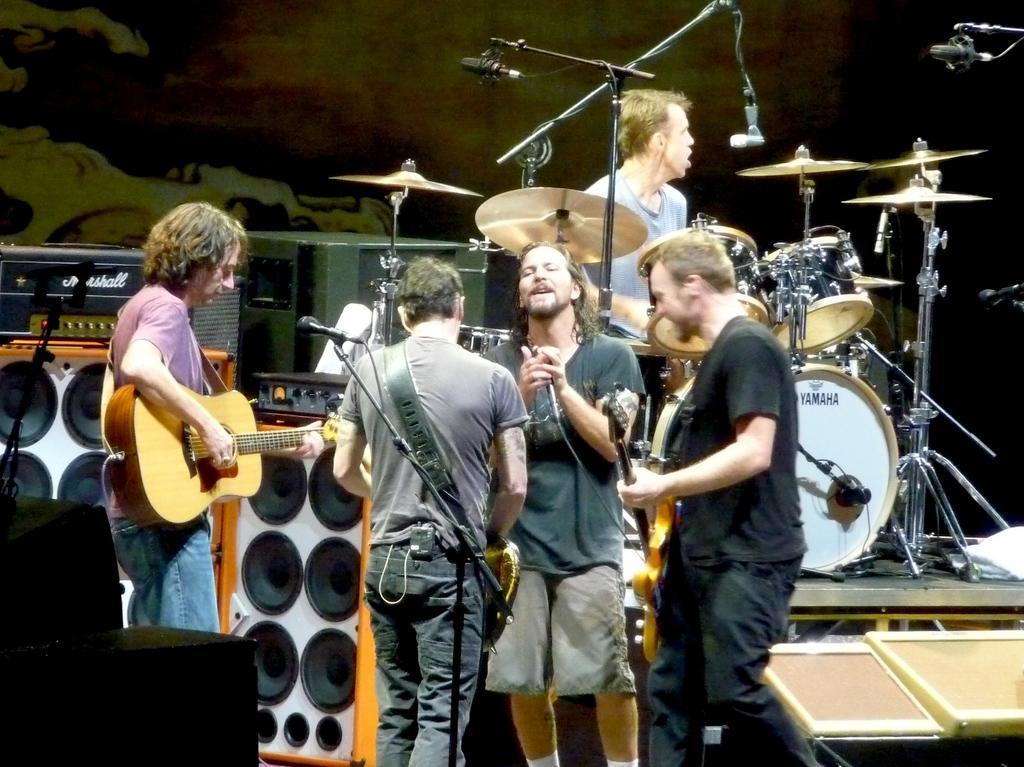Could you give a brief overview of what you see in this image? There are four persons standing among them three persons are playing guitar and one person is signing a song. This is the mike with the mike stand. These are the speakers. here is the another person sitting and playing drums. 